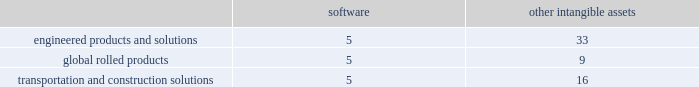Discounted cash flow model ( dcf ) to estimate the current fair value of its reporting units when testing for impairment , as management believes forecasted cash flows are the best indicator of such fair value .
A number of significant assumptions and estimates are involved in the application of the dcf model to forecast operating cash flows , including sales growth ( volumes and pricing ) , production costs , capital spending , and discount rate .
Most of these assumptions vary significantly among the reporting units .
Cash flow forecasts are generally based on approved business unit operating plans for the early years and historical relationships in later years .
The wacc rate for the individual reporting units is estimated with the assistance of valuation experts .
Arconic would recognize an impairment charge for the amount by which the carrying amount exceeds the reporting unit 2019s fair value without exceeding the total amount of goodwill allocated to that reporting unit .
In connection with the interim impairment evaluation of long-lived assets for the disks operations ( an asset group within the aen business unit ) in the second quarter of 2018 , which resulted from a decline in forecasted financial performance for the business in connection with its updated three-year strategic plan , the company also performed an interim impairment evaluation of goodwill for the aen reporting unit .
The estimated fair value of the reporting unit was substantially in excess of the carrying value ; thus , there was no impairment of goodwill .
Goodwill impairment tests in 2017 and 2016 indicated that goodwill was not impaired for any of the company 2019s reporting units , except for the arconic forgings and extrusions ( afe ) business whose estimated fair value was lower than its carrying value .
As such , arconic recorded an impairment for the full amount of goodwill in the afe reporting unit of $ 719 .
The decrease in the afe fair value was primarily due to unfavorable performance that was impacting operating margins and a higher discount rate due to an increase in the risk-free rate of return , while the carrying value increased compared to prior year .
Other intangible assets .
Intangible assets with indefinite useful lives are not amortized while intangible assets with finite useful lives are amortized generally on a straight-line basis over the periods benefited .
The table details the weighted- average useful lives of software and other intangible assets by reporting segment ( numbers in years ) : .
Revenue recognition .
The company's contracts with customers are comprised of acknowledged purchase orders incorporating the company 2019s standard terms and conditions , or for larger customers , may also generally include terms under negotiated multi-year agreements .
These contracts with customers typically consist of the manufacture of products which represent single performance obligations that are satisfied upon transfer of control of the product to the customer .
The company produces fastening systems ; seamless rolled rings ; investment castings , including airfoils and forged jet engine components ; extruded , machined and formed aircraft parts ; aluminum sheet and plate ; integrated aluminum structural systems ; architectural extrusions ; and forged aluminum commercial vehicle wheels .
Transfer of control is assessed based on alternative use of the products we produce and our enforceable right to payment for performance to date under the contract terms .
Transfer of control and revenue recognition generally occur upon shipment or delivery of the product , which is when title , ownership and risk of loss pass to the customer and is based on the applicable shipping terms .
The shipping terms vary across all businesses and depend on the product , the country of origin , and the type of transportation ( truck , train , or vessel ) .
An invoice for payment is issued at time of shipment .
The company 2019s objective is to have net 30-day terms .
Our business units set commercial terms on which arconic sells products to its customers .
These terms are influenced by industry custom , market conditions , product line ( specialty versus commodity products ) , and other considerations .
In certain circumstances , arconic receives advanced payments from its customers for product to be delivered in future periods .
These advanced payments are recorded as deferred revenue until the product is delivered and title and risk of loss have passed to the customer in accordance with the terms of the contract .
Deferred revenue is included in other current liabilities and other noncurrent liabilities and deferred credits on the accompanying consolidated balance sheet .
Environmental matters .
Expenditures for current operations are expensed or capitalized , as appropriate .
Expenditures relating to existing conditions caused by past operations , which will not contribute to future revenues , are expensed .
Liabilities are recorded when remediation costs are probable and can be reasonably estimated .
The liability may include costs such as site investigations , consultant fees , feasibility studies , outside contractors , and monitoring expenses .
Estimates are generally not discounted or reduced by potential claims for recovery .
Claims for recovery are recognized when probable and as agreements are reached with third parties .
The estimates also include costs related to other potentially responsible parties to the extent that arconic has reason to believe such parties will not fully pay their proportionate share .
The liability is continuously reviewed and adjusted to reflect current remediation progress , prospective estimates of required activity , and other factors that may be relevant , including changes in technology or regulations .
Litigation matters .
For asserted claims and assessments , liabilities are recorded when an unfavorable outcome of a matter is .
How long is the weighted- average useful lives of other assets , as a percent of software in the engineered products and solutions segment? 
Rationale: it is the weighted- average useful lives of software ( 5 years ) divided by the weighted- average useful lives of other assets ( 33 years ) , then minus 100% .
Computations: (((33 / 5) * 100) - 100)
Answer: 560.0. 